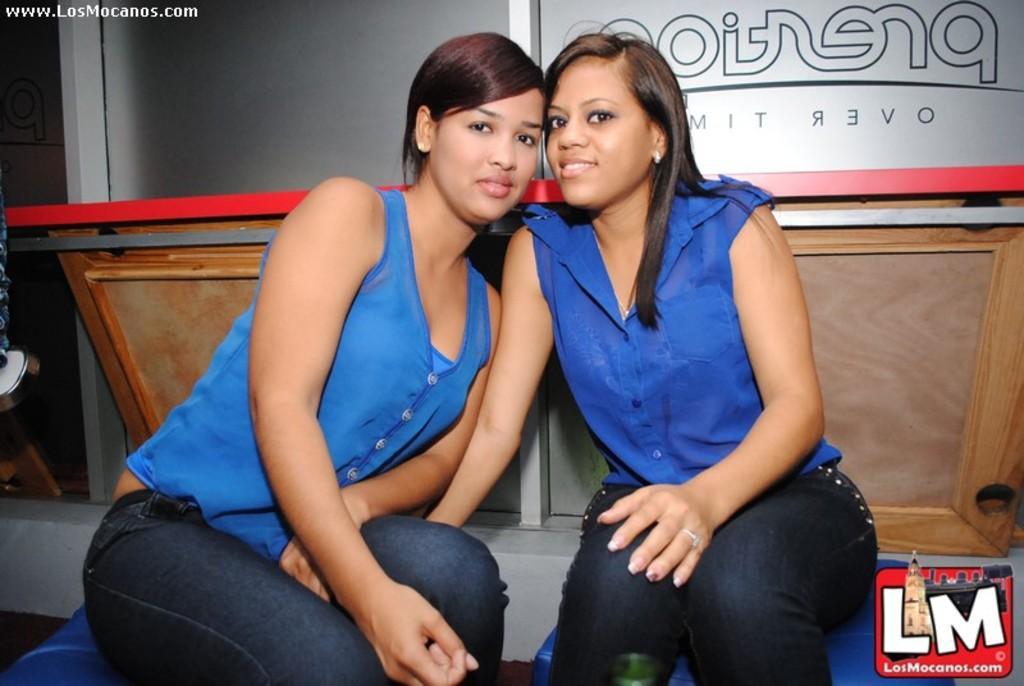How would you summarize this image in a sentence or two? In the foreground of this image, there are two women in blue shirts are sitting on blue stools. In the background, there is a glass wall, some wooden planks like an object and a red straight plane object. 